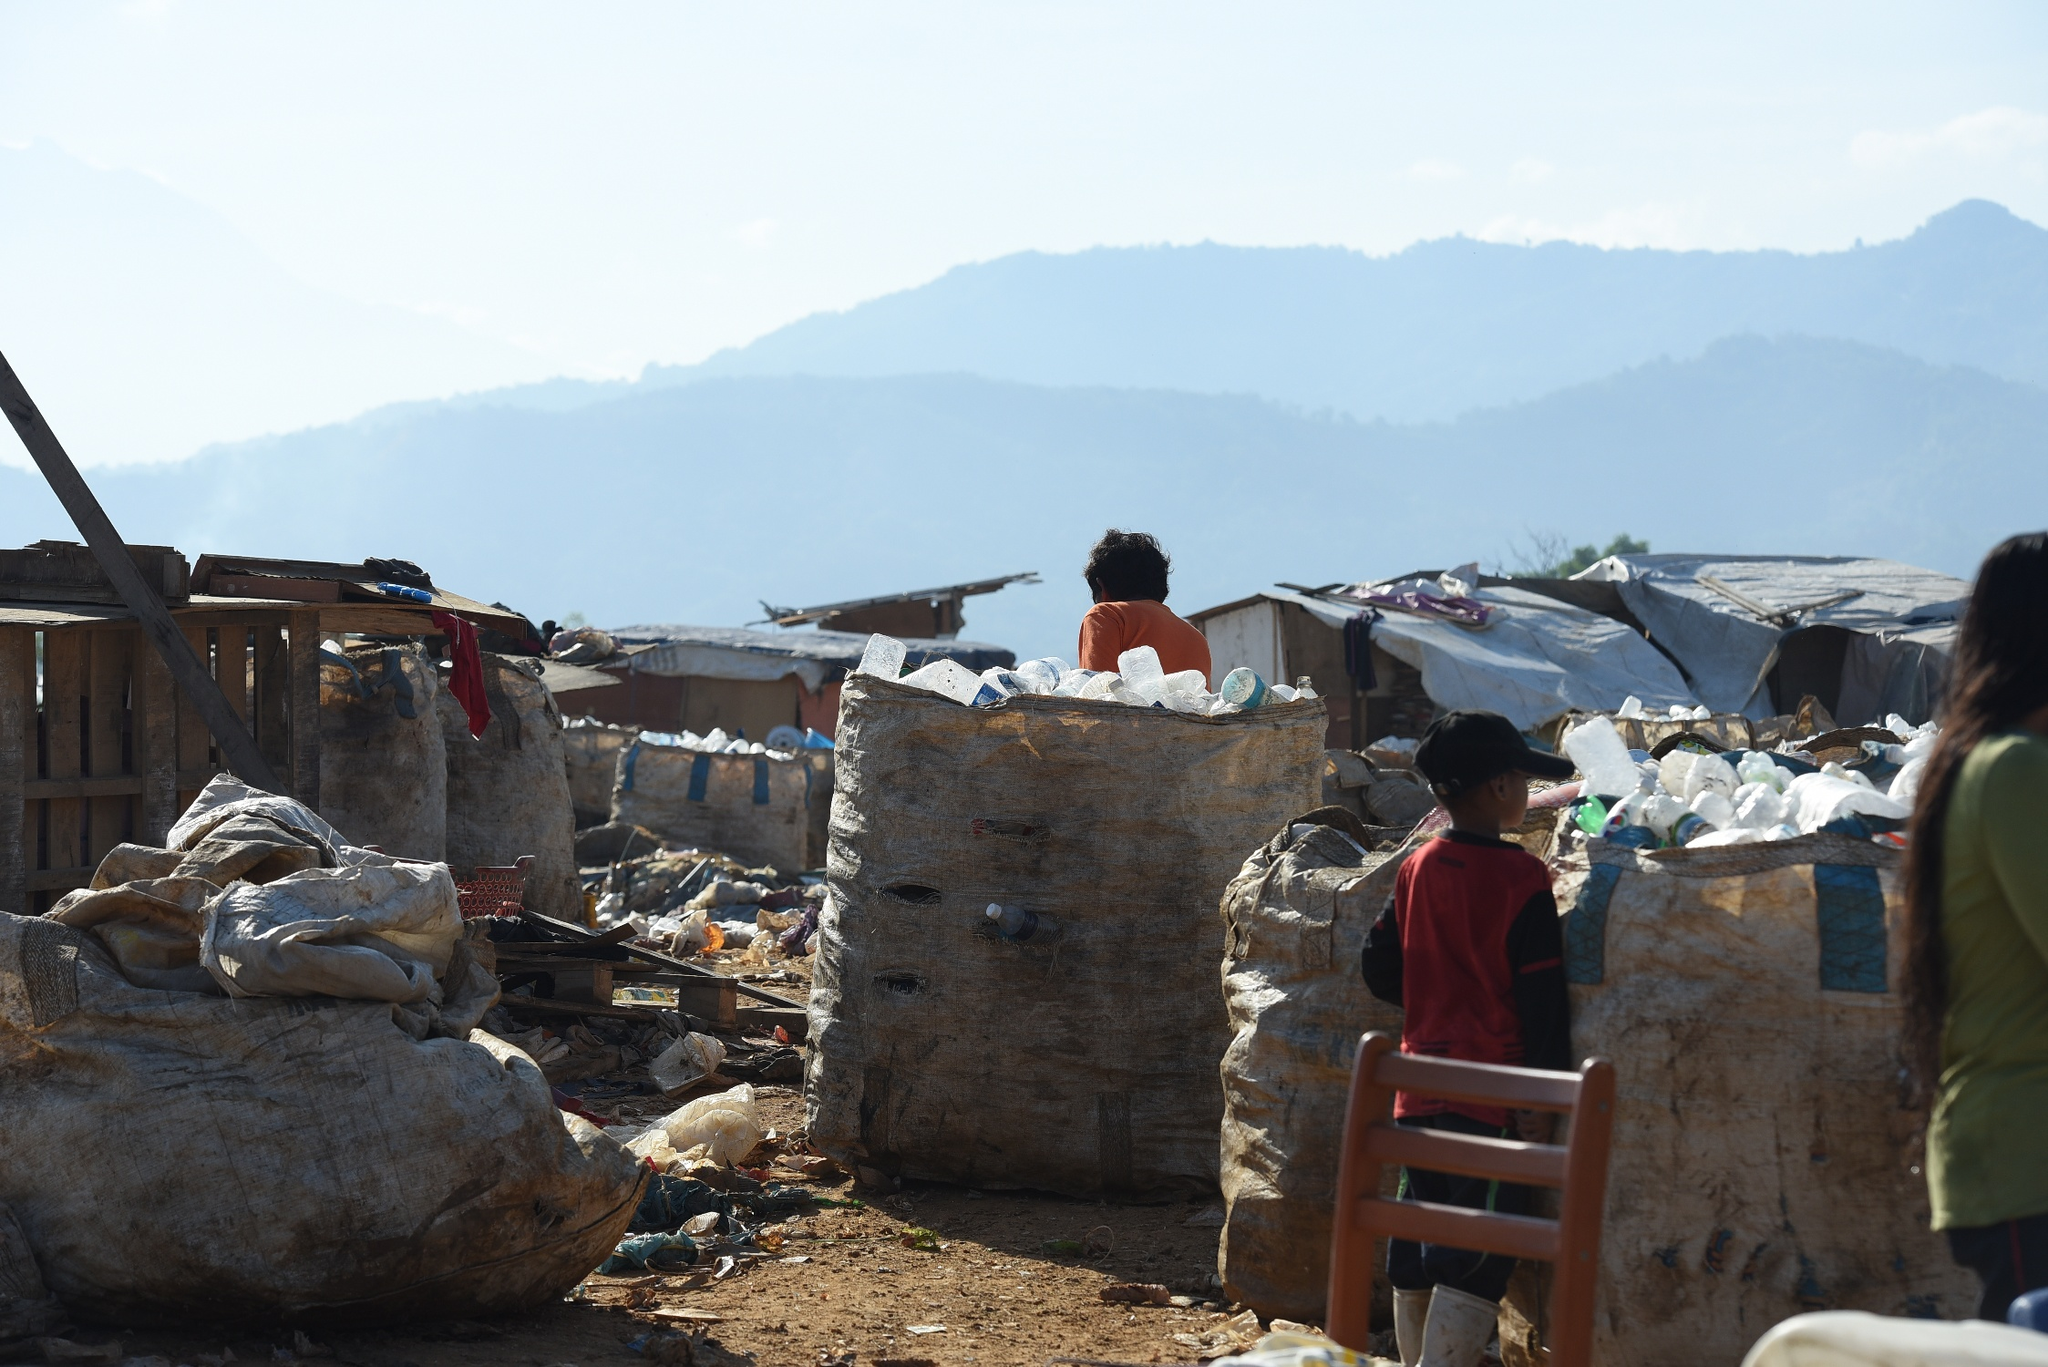Describe the environmental impact depicted in this image. This image powerfully illustrates the environmental impact of rampant waste generation and inadequate waste management. The large numbers of plastic bottles and other waste materials signify a substantial burden on the local ecosystem. The vast amount of unrecycled plastic poses significant risks to soil quality, water sources, and wildlife. Furthermore, the contrast with the natural backdrop of mountains highlights the encroachment of human activity into natural spaces, serving as a stark visual reminder of the urgent need for sustainable waste management practices and greater environmental stewardship. How can communities take action to prevent scenes like this? Communities can take several impactful actions to prevent the emergence of landfill sites like the one depicted. Firstly, implementing comprehensive recycling programs can drastically reduce the volume of waste that ends up in landfills. Education campaigns to raise awareness about the importance of reducing, reusing, and recycling can further bolster these efforts. Additionally, community clean-up events can mobilize residents to actively participate in maintaining local environments. Municipalities can invest in more efficient waste collection and segregation systems to ensure that recyclable materials are properly processed. Encouraging the use of biodegradable products and reducing single-use plastics among households can significantly diminish long-term waste accumulation. Finally, supporting policies promoting sustainable manufacturing and consumption at the governmental level is essential for long-term environmental health. 